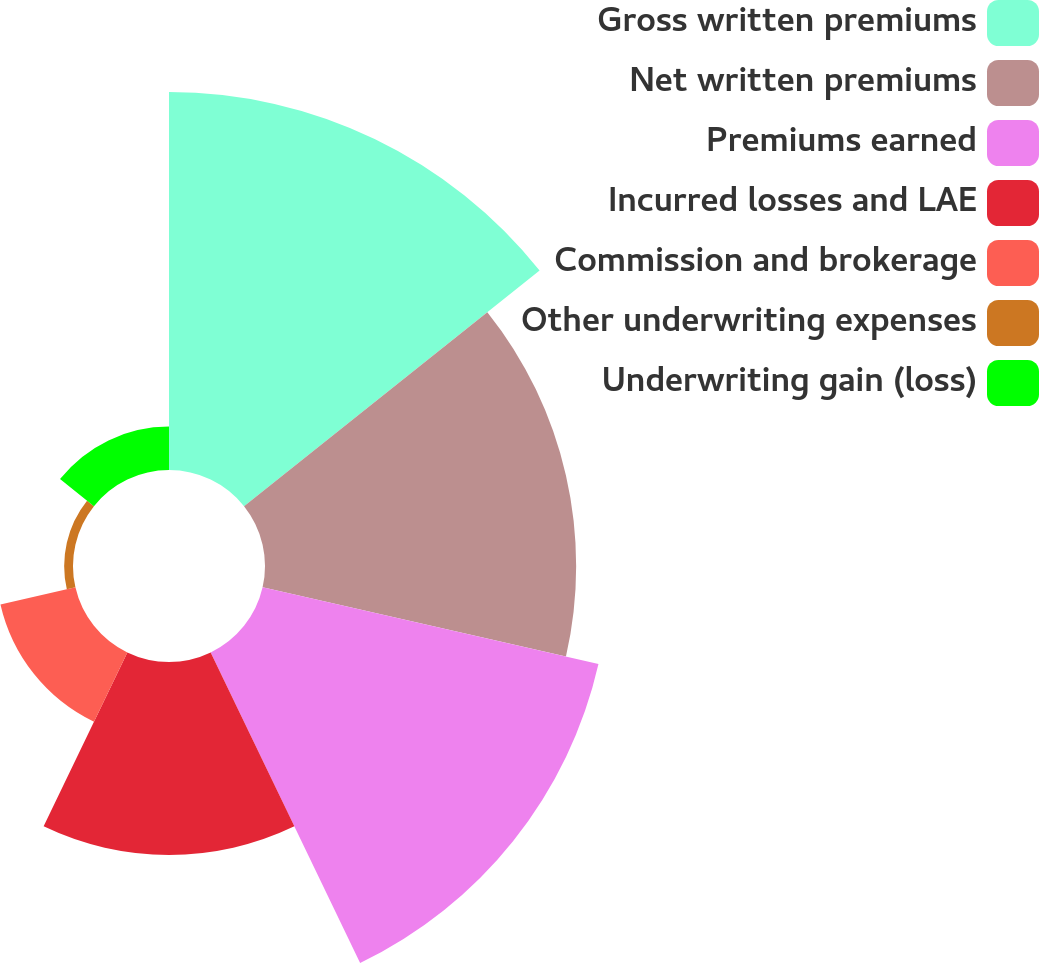<chart> <loc_0><loc_0><loc_500><loc_500><pie_chart><fcel>Gross written premiums<fcel>Net written premiums<fcel>Premiums earned<fcel>Incurred losses and LAE<fcel>Commission and brokerage<fcel>Other underwriting expenses<fcel>Underwriting gain (loss)<nl><fcel>27.88%<fcel>22.95%<fcel>25.41%<fcel>14.23%<fcel>5.67%<fcel>0.65%<fcel>3.2%<nl></chart> 